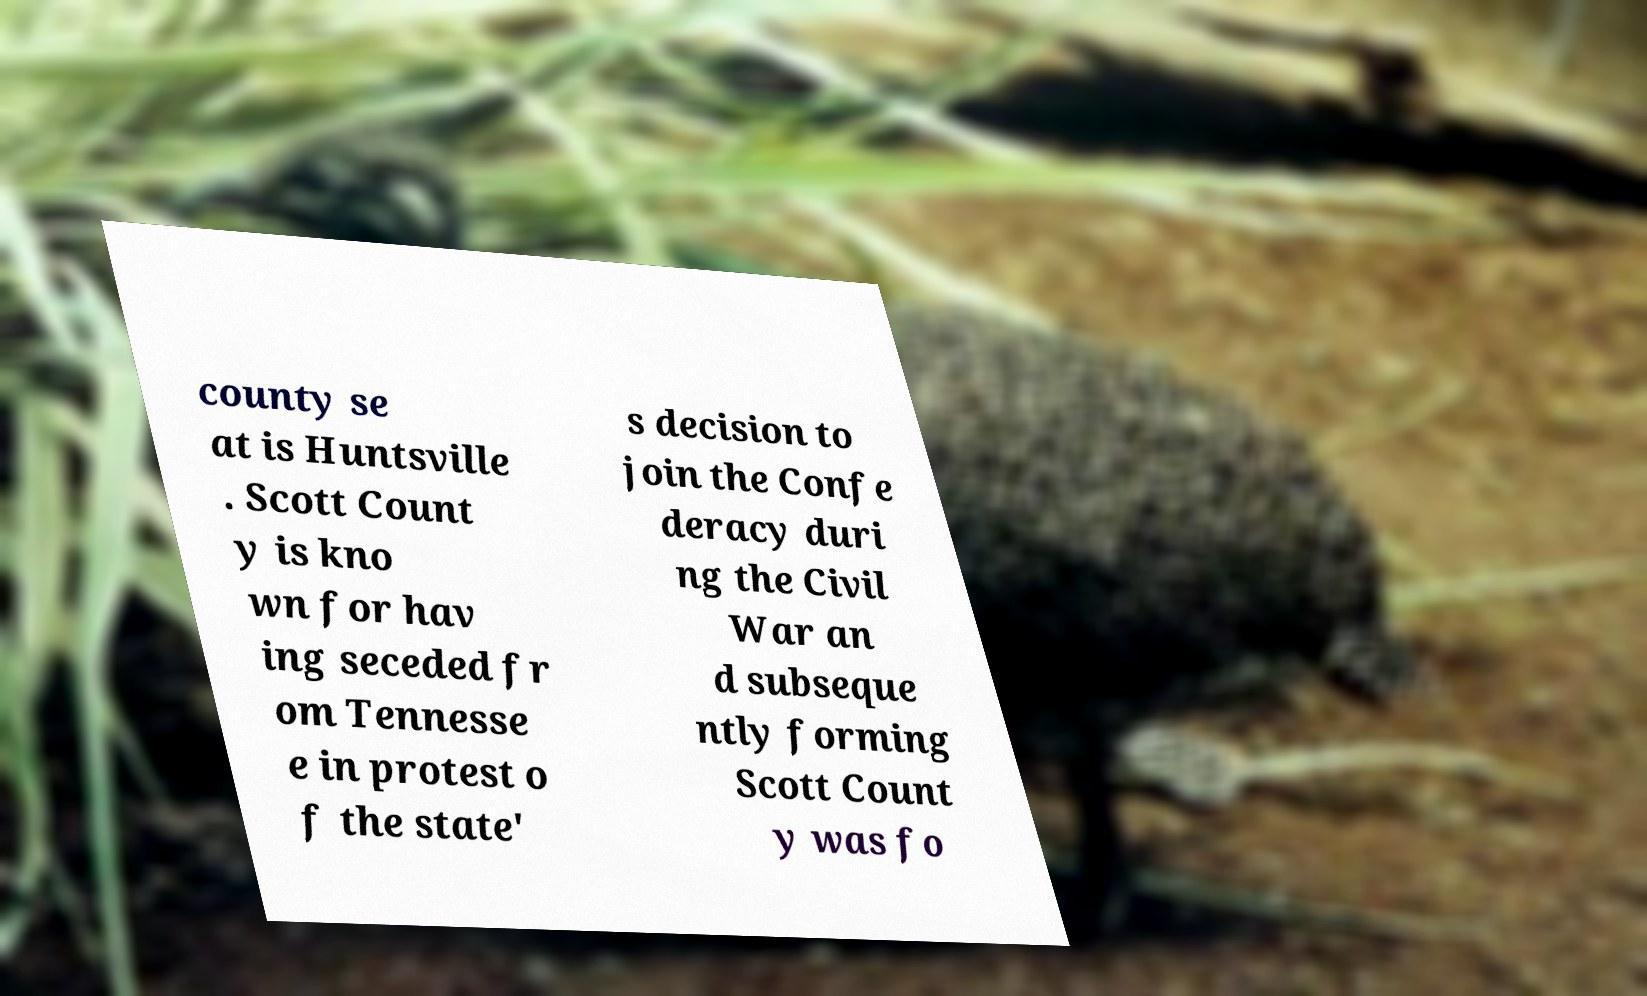What messages or text are displayed in this image? I need them in a readable, typed format. county se at is Huntsville . Scott Count y is kno wn for hav ing seceded fr om Tennesse e in protest o f the state' s decision to join the Confe deracy duri ng the Civil War an d subseque ntly forming Scott Count y was fo 